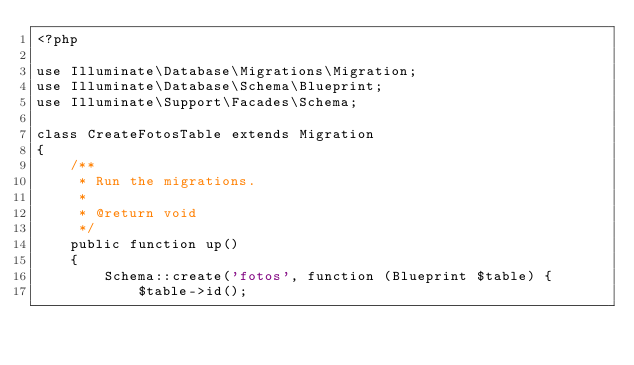<code> <loc_0><loc_0><loc_500><loc_500><_PHP_><?php

use Illuminate\Database\Migrations\Migration;
use Illuminate\Database\Schema\Blueprint;
use Illuminate\Support\Facades\Schema;

class CreateFotosTable extends Migration
{
    /**
     * Run the migrations.
     *
     * @return void
     */
    public function up()
    {
        Schema::create('fotos', function (Blueprint $table) {
            $table->id();</code> 